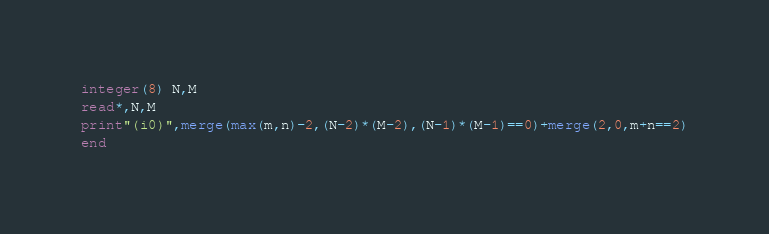<code> <loc_0><loc_0><loc_500><loc_500><_FORTRAN_>integer(8) N,M
read*,N,M
print"(i0)",merge(max(m,n)-2,(N-2)*(M-2),(N-1)*(M-1)==0)+merge(2,0,m+n==2)
end</code> 